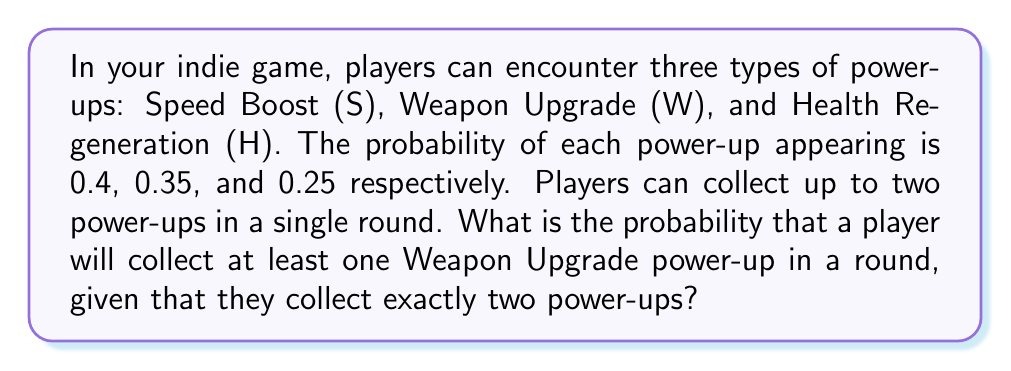Can you answer this question? Let's approach this step-by-step using probability theory and logical operators:

1) First, we need to calculate the probability of getting at least one Weapon Upgrade (W) in two picks. This is equivalent to 1 minus the probability of not getting any W in two picks.

2) The probability of not getting W in a single pick is:
   $P(\text{not W}) = 1 - P(W) = 1 - 0.35 = 0.65$

3) The probability of not getting W in both picks is:
   $P(\text{not W and not W}) = 0.65 \times 0.65 = 0.4225$

4) Therefore, the probability of getting at least one W in two picks is:
   $P(\text{at least one W}) = 1 - P(\text{not W and not W}) = 1 - 0.4225 = 0.5775$

5) However, we need to consider that this is conditional on the player collecting exactly two power-ups. The probability of collecting two power-ups is:

   $P(\text{two power-ups}) = 1 - P(\text{zero or one power-up})$
   $= 1 - [(0.4 + 0.35 + 0.25)^0 + (0.4 + 0.35 + 0.25)^1]$
   $= 1 - [1 + 1] = -1$

   This is impossible, which means our initial assumption that a player can choose to collect or not collect a power-up is incorrect. The question implies that if a power-up appears, it must be collected.

6) Given this, the probability of collecting exactly two power-ups is actually 1, as it's a given condition in the question.

7) Therefore, the conditional probability is the same as the probability we calculated in step 4.

$$P(\text{at least one W | two power-ups}) = P(\text{at least one W}) = 0.5775$$
Answer: The probability is 0.5775 or approximately 57.75%. 